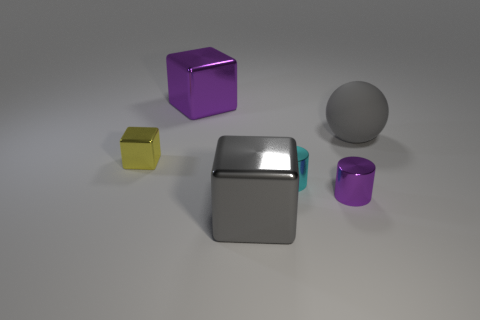Is there any other thing that is the same material as the ball?
Your answer should be very brief. No. There is a metallic object that is behind the small purple metallic cylinder and in front of the yellow shiny thing; how big is it?
Offer a terse response. Small. There is a tiny thing to the left of the large purple metallic object; is it the same color as the big sphere?
Provide a short and direct response. No. Is the number of purple things that are to the left of the small purple metal cylinder less than the number of small rubber spheres?
Offer a terse response. No. There is a big gray object that is made of the same material as the big purple object; what shape is it?
Give a very brief answer. Cube. Is the material of the tiny purple thing the same as the big purple block?
Provide a succinct answer. Yes. Is the number of objects in front of the yellow cube less than the number of objects behind the gray metal block?
Your answer should be compact. Yes. What size is the thing that is the same color as the ball?
Provide a short and direct response. Large. There is a tiny cyan metallic object that is in front of the purple object that is behind the small cube; how many large gray spheres are on the left side of it?
Your answer should be compact. 0. Do the rubber ball and the small metal cube have the same color?
Your answer should be compact. No. 